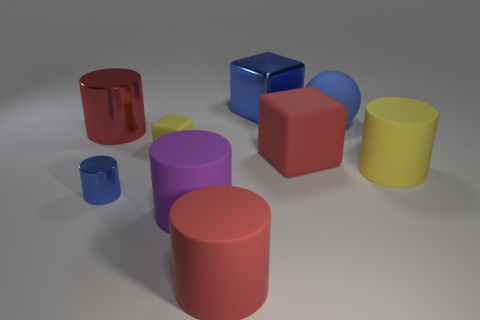What is the size of the rubber ball that is the same color as the small shiny object?
Give a very brief answer. Large. What number of spheres have the same color as the metal cube?
Offer a terse response. 1. What number of big yellow cylinders are behind the big blue thing on the left side of the blue matte thing?
Provide a succinct answer. 0. Is the size of the yellow cylinder the same as the rubber block left of the large blue block?
Give a very brief answer. No. Are there any blue shiny cubes of the same size as the yellow matte cylinder?
Ensure brevity in your answer.  Yes. How many things are either purple blocks or tiny yellow objects?
Keep it short and to the point. 1. Do the cube that is to the left of the big purple rubber thing and the red thing left of the tiny rubber object have the same size?
Keep it short and to the point. No. Is there another tiny yellow object of the same shape as the small yellow rubber thing?
Offer a very short reply. No. Are there fewer big blue balls in front of the yellow rubber cylinder than tiny blue objects?
Your answer should be very brief. Yes. Is the shape of the large blue shiny thing the same as the purple rubber thing?
Keep it short and to the point. No. 